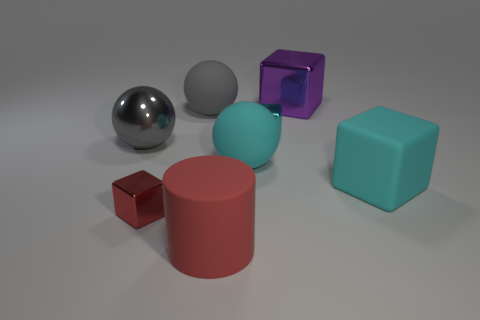Subtract all cyan balls. How many balls are left? 2 Subtract 3 cubes. How many cubes are left? 1 Add 2 big shiny cylinders. How many objects exist? 10 Subtract all cyan balls. How many balls are left? 2 Subtract all blue spheres. Subtract all yellow cylinders. How many spheres are left? 3 Subtract all red blocks. How many purple cylinders are left? 0 Subtract all metallic spheres. Subtract all big gray objects. How many objects are left? 5 Add 4 large matte balls. How many large matte balls are left? 6 Add 1 large yellow rubber spheres. How many large yellow rubber spheres exist? 1 Subtract 1 red cylinders. How many objects are left? 7 